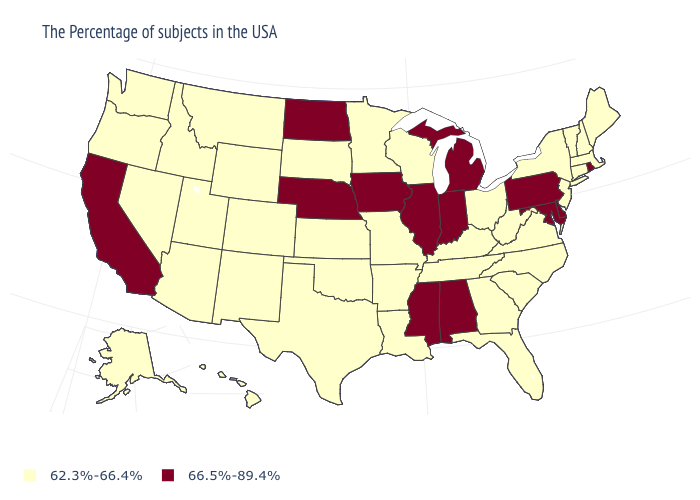What is the value of Iowa?
Answer briefly. 66.5%-89.4%. Which states hav the highest value in the West?
Answer briefly. California. Does North Carolina have a lower value than North Dakota?
Answer briefly. Yes. Name the states that have a value in the range 66.5%-89.4%?
Quick response, please. Rhode Island, Delaware, Maryland, Pennsylvania, Michigan, Indiana, Alabama, Illinois, Mississippi, Iowa, Nebraska, North Dakota, California. What is the lowest value in the USA?
Short answer required. 62.3%-66.4%. Name the states that have a value in the range 66.5%-89.4%?
Short answer required. Rhode Island, Delaware, Maryland, Pennsylvania, Michigan, Indiana, Alabama, Illinois, Mississippi, Iowa, Nebraska, North Dakota, California. Name the states that have a value in the range 62.3%-66.4%?
Quick response, please. Maine, Massachusetts, New Hampshire, Vermont, Connecticut, New York, New Jersey, Virginia, North Carolina, South Carolina, West Virginia, Ohio, Florida, Georgia, Kentucky, Tennessee, Wisconsin, Louisiana, Missouri, Arkansas, Minnesota, Kansas, Oklahoma, Texas, South Dakota, Wyoming, Colorado, New Mexico, Utah, Montana, Arizona, Idaho, Nevada, Washington, Oregon, Alaska, Hawaii. How many symbols are there in the legend?
Concise answer only. 2. Name the states that have a value in the range 66.5%-89.4%?
Short answer required. Rhode Island, Delaware, Maryland, Pennsylvania, Michigan, Indiana, Alabama, Illinois, Mississippi, Iowa, Nebraska, North Dakota, California. Name the states that have a value in the range 66.5%-89.4%?
Give a very brief answer. Rhode Island, Delaware, Maryland, Pennsylvania, Michigan, Indiana, Alabama, Illinois, Mississippi, Iowa, Nebraska, North Dakota, California. Name the states that have a value in the range 66.5%-89.4%?
Write a very short answer. Rhode Island, Delaware, Maryland, Pennsylvania, Michigan, Indiana, Alabama, Illinois, Mississippi, Iowa, Nebraska, North Dakota, California. Name the states that have a value in the range 62.3%-66.4%?
Concise answer only. Maine, Massachusetts, New Hampshire, Vermont, Connecticut, New York, New Jersey, Virginia, North Carolina, South Carolina, West Virginia, Ohio, Florida, Georgia, Kentucky, Tennessee, Wisconsin, Louisiana, Missouri, Arkansas, Minnesota, Kansas, Oklahoma, Texas, South Dakota, Wyoming, Colorado, New Mexico, Utah, Montana, Arizona, Idaho, Nevada, Washington, Oregon, Alaska, Hawaii. What is the value of New Mexico?
Quick response, please. 62.3%-66.4%. Name the states that have a value in the range 62.3%-66.4%?
Write a very short answer. Maine, Massachusetts, New Hampshire, Vermont, Connecticut, New York, New Jersey, Virginia, North Carolina, South Carolina, West Virginia, Ohio, Florida, Georgia, Kentucky, Tennessee, Wisconsin, Louisiana, Missouri, Arkansas, Minnesota, Kansas, Oklahoma, Texas, South Dakota, Wyoming, Colorado, New Mexico, Utah, Montana, Arizona, Idaho, Nevada, Washington, Oregon, Alaska, Hawaii. 